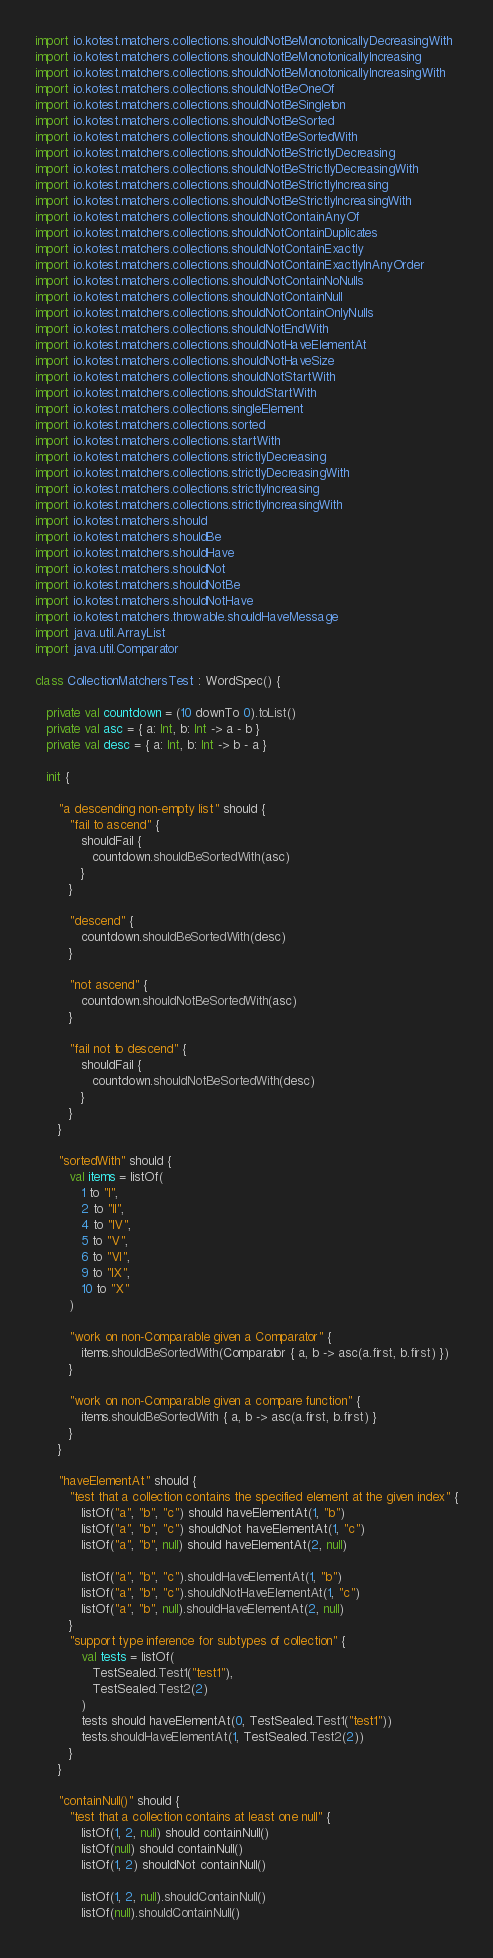<code> <loc_0><loc_0><loc_500><loc_500><_Kotlin_>import io.kotest.matchers.collections.shouldNotBeMonotonicallyDecreasingWith
import io.kotest.matchers.collections.shouldNotBeMonotonicallyIncreasing
import io.kotest.matchers.collections.shouldNotBeMonotonicallyIncreasingWith
import io.kotest.matchers.collections.shouldNotBeOneOf
import io.kotest.matchers.collections.shouldNotBeSingleton
import io.kotest.matchers.collections.shouldNotBeSorted
import io.kotest.matchers.collections.shouldNotBeSortedWith
import io.kotest.matchers.collections.shouldNotBeStrictlyDecreasing
import io.kotest.matchers.collections.shouldNotBeStrictlyDecreasingWith
import io.kotest.matchers.collections.shouldNotBeStrictlyIncreasing
import io.kotest.matchers.collections.shouldNotBeStrictlyIncreasingWith
import io.kotest.matchers.collections.shouldNotContainAnyOf
import io.kotest.matchers.collections.shouldNotContainDuplicates
import io.kotest.matchers.collections.shouldNotContainExactly
import io.kotest.matchers.collections.shouldNotContainExactlyInAnyOrder
import io.kotest.matchers.collections.shouldNotContainNoNulls
import io.kotest.matchers.collections.shouldNotContainNull
import io.kotest.matchers.collections.shouldNotContainOnlyNulls
import io.kotest.matchers.collections.shouldNotEndWith
import io.kotest.matchers.collections.shouldNotHaveElementAt
import io.kotest.matchers.collections.shouldNotHaveSize
import io.kotest.matchers.collections.shouldNotStartWith
import io.kotest.matchers.collections.shouldStartWith
import io.kotest.matchers.collections.singleElement
import io.kotest.matchers.collections.sorted
import io.kotest.matchers.collections.startWith
import io.kotest.matchers.collections.strictlyDecreasing
import io.kotest.matchers.collections.strictlyDecreasingWith
import io.kotest.matchers.collections.strictlyIncreasing
import io.kotest.matchers.collections.strictlyIncreasingWith
import io.kotest.matchers.should
import io.kotest.matchers.shouldBe
import io.kotest.matchers.shouldHave
import io.kotest.matchers.shouldNot
import io.kotest.matchers.shouldNotBe
import io.kotest.matchers.shouldNotHave
import io.kotest.matchers.throwable.shouldHaveMessage
import java.util.ArrayList
import java.util.Comparator

class CollectionMatchersTest : WordSpec() {

   private val countdown = (10 downTo 0).toList()
   private val asc = { a: Int, b: Int -> a - b }
   private val desc = { a: Int, b: Int -> b - a }

   init {

      "a descending non-empty list" should {
         "fail to ascend" {
            shouldFail {
               countdown.shouldBeSortedWith(asc)
            }
         }

         "descend" {
            countdown.shouldBeSortedWith(desc)
         }

         "not ascend" {
            countdown.shouldNotBeSortedWith(asc)
         }

         "fail not to descend" {
            shouldFail {
               countdown.shouldNotBeSortedWith(desc)
            }
         }
      }

      "sortedWith" should {
         val items = listOf(
            1 to "I",
            2 to "II",
            4 to "IV",
            5 to "V",
            6 to "VI",
            9 to "IX",
            10 to "X"
         )

         "work on non-Comparable given a Comparator" {
            items.shouldBeSortedWith(Comparator { a, b -> asc(a.first, b.first) })
         }

         "work on non-Comparable given a compare function" {
            items.shouldBeSortedWith { a, b -> asc(a.first, b.first) }
         }
      }

      "haveElementAt" should {
         "test that a collection contains the specified element at the given index" {
            listOf("a", "b", "c") should haveElementAt(1, "b")
            listOf("a", "b", "c") shouldNot haveElementAt(1, "c")
            listOf("a", "b", null) should haveElementAt(2, null)

            listOf("a", "b", "c").shouldHaveElementAt(1, "b")
            listOf("a", "b", "c").shouldNotHaveElementAt(1, "c")
            listOf("a", "b", null).shouldHaveElementAt(2, null)
         }
         "support type inference for subtypes of collection" {
            val tests = listOf(
               TestSealed.Test1("test1"),
               TestSealed.Test2(2)
            )
            tests should haveElementAt(0, TestSealed.Test1("test1"))
            tests.shouldHaveElementAt(1, TestSealed.Test2(2))
         }
      }

      "containNull()" should {
         "test that a collection contains at least one null" {
            listOf(1, 2, null) should containNull()
            listOf(null) should containNull()
            listOf(1, 2) shouldNot containNull()

            listOf(1, 2, null).shouldContainNull()
            listOf(null).shouldContainNull()</code> 